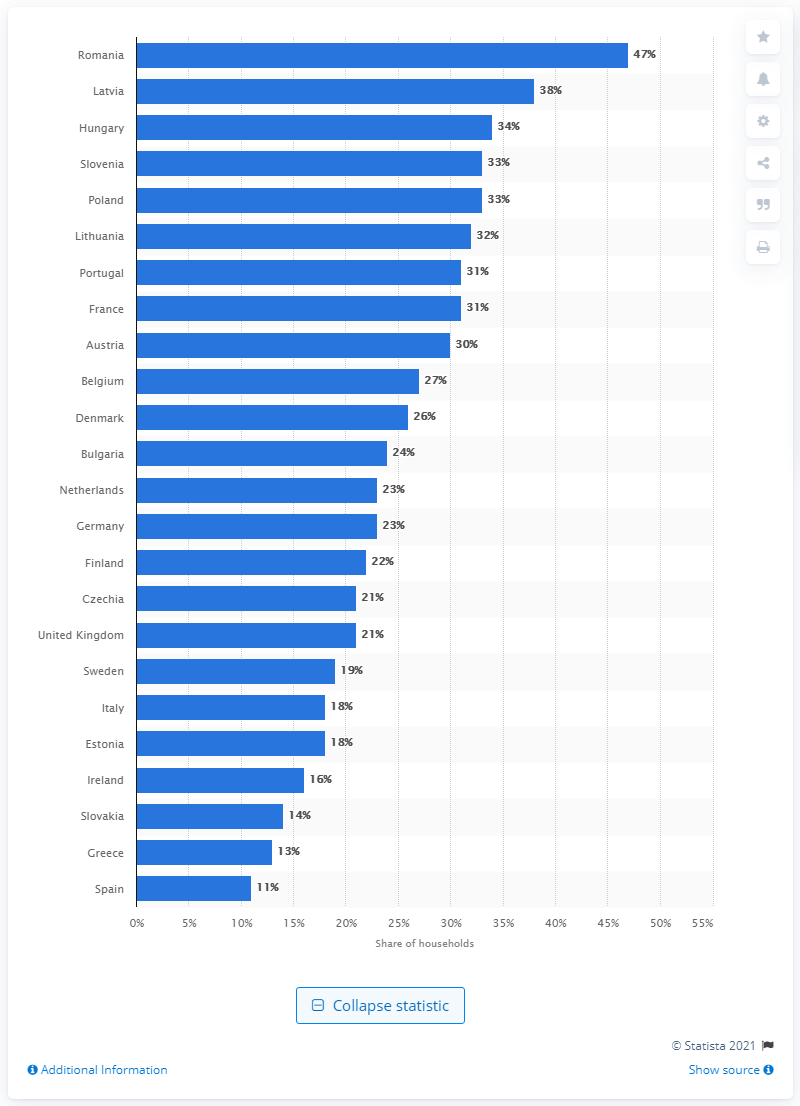Indicate a few pertinent items in this graphic. According to a survey conducted in 2019, Latvia had the highest percentage of households owning cats out of all the countries surveyed. 